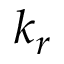<formula> <loc_0><loc_0><loc_500><loc_500>k _ { r }</formula> 